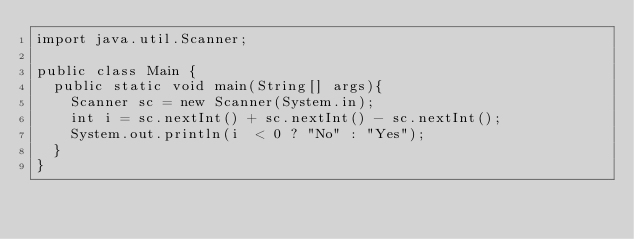<code> <loc_0><loc_0><loc_500><loc_500><_Java_>import java.util.Scanner;

public class Main {
	public static void main(String[] args){
		Scanner sc = new Scanner(System.in);
		int i = sc.nextInt() + sc.nextInt() - sc.nextInt();
		System.out.println(i  < 0 ? "No" : "Yes");
	}
}</code> 